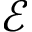Convert formula to latex. <formula><loc_0><loc_0><loc_500><loc_500>\mathcal { E }</formula> 